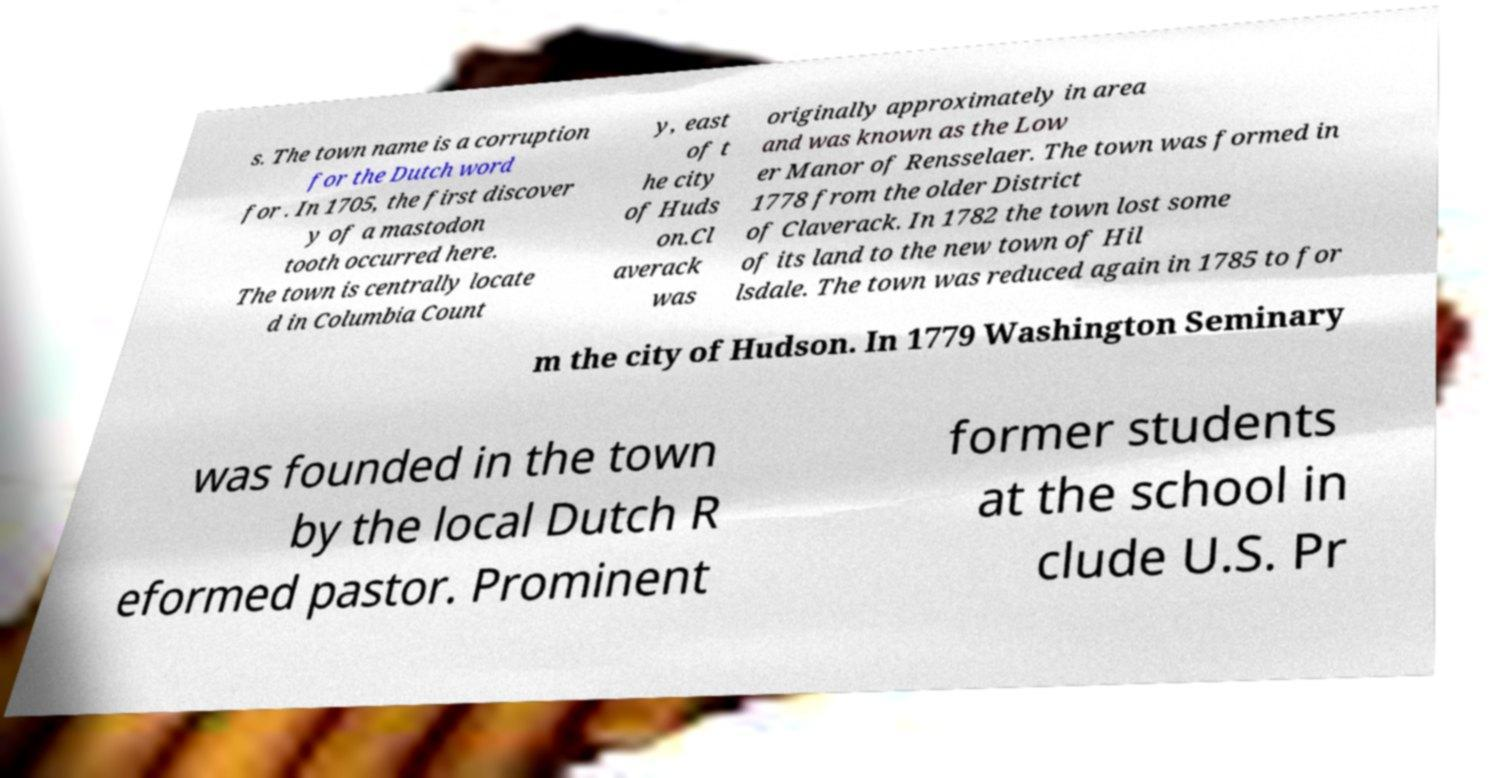I need the written content from this picture converted into text. Can you do that? s. The town name is a corruption for the Dutch word for . In 1705, the first discover y of a mastodon tooth occurred here. The town is centrally locate d in Columbia Count y, east of t he city of Huds on.Cl averack was originally approximately in area and was known as the Low er Manor of Rensselaer. The town was formed in 1778 from the older District of Claverack. In 1782 the town lost some of its land to the new town of Hil lsdale. The town was reduced again in 1785 to for m the city of Hudson. In 1779 Washington Seminary was founded in the town by the local Dutch R eformed pastor. Prominent former students at the school in clude U.S. Pr 